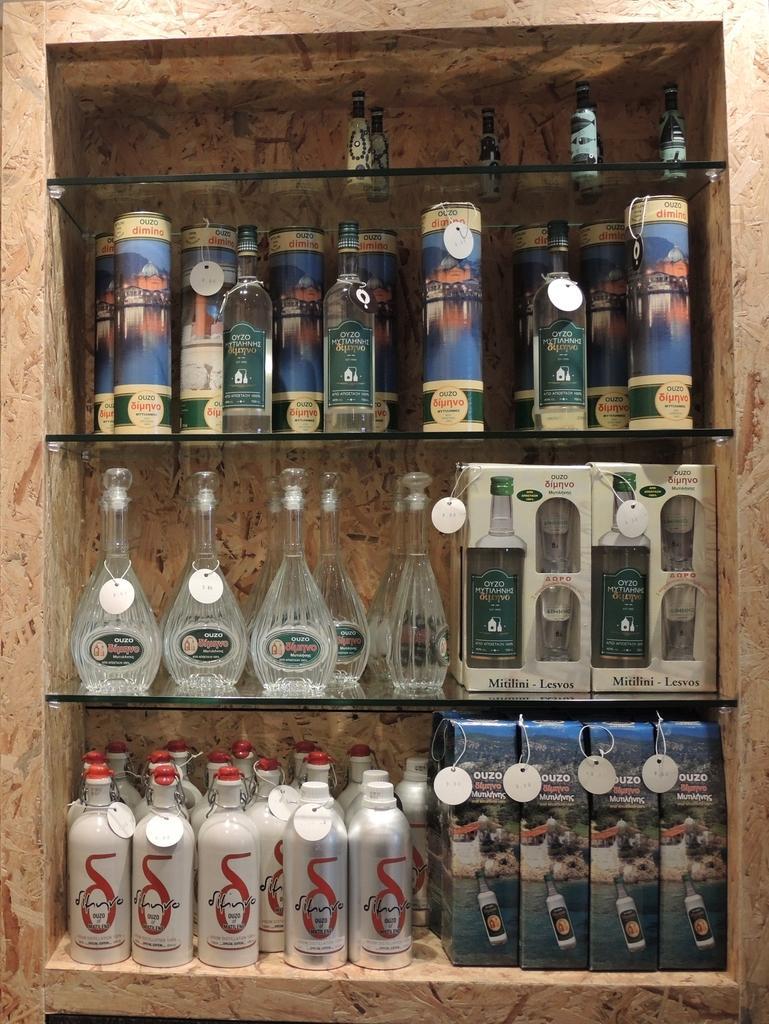Describe this image in one or two sentences. In this image we can see a different brand of wine bottles which are kept on this glass shelf. 